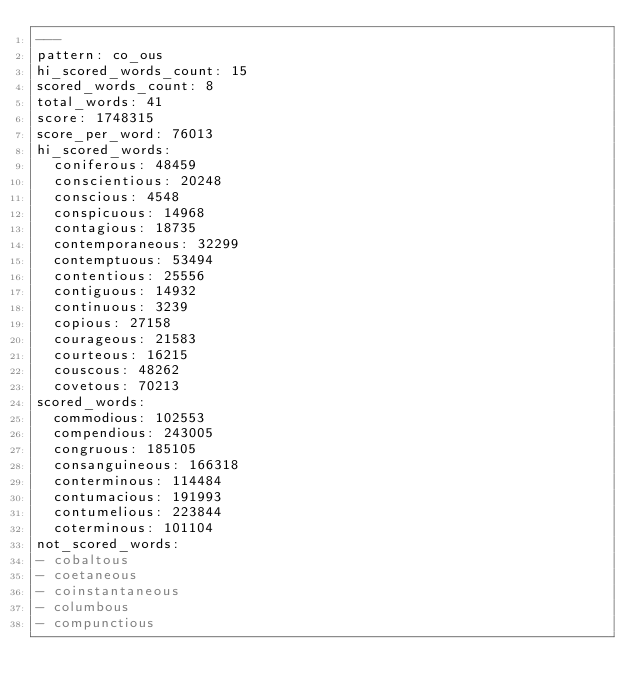<code> <loc_0><loc_0><loc_500><loc_500><_YAML_>---
pattern: co_ous
hi_scored_words_count: 15
scored_words_count: 8
total_words: 41
score: 1748315
score_per_word: 76013
hi_scored_words:
  coniferous: 48459
  conscientious: 20248
  conscious: 4548
  conspicuous: 14968
  contagious: 18735
  contemporaneous: 32299
  contemptuous: 53494
  contentious: 25556
  contiguous: 14932
  continuous: 3239
  copious: 27158
  courageous: 21583
  courteous: 16215
  couscous: 48262
  covetous: 70213
scored_words:
  commodious: 102553
  compendious: 243005
  congruous: 185105
  consanguineous: 166318
  conterminous: 114484
  contumacious: 191993
  contumelious: 223844
  coterminous: 101104
not_scored_words:
- cobaltous
- coetaneous
- coinstantaneous
- columbous
- compunctious</code> 